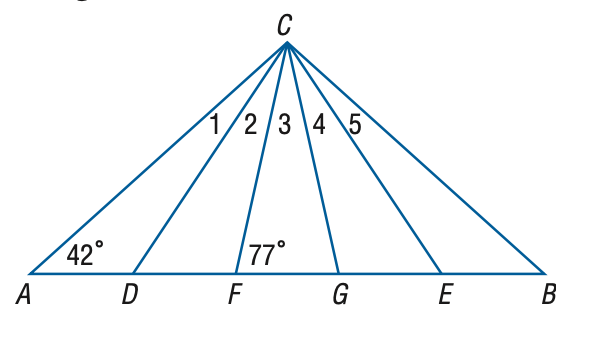Answer the mathemtical geometry problem and directly provide the correct option letter.
Question: In the figure, \triangle A B C is isosceles, \triangle D C E is equilateral, and \triangle F C G is isosceles. Find the measure of the \angle 4 at vertex C.
Choices: A: 15 B: 16 C: 17 D: 18 C 